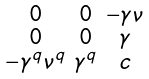<formula> <loc_0><loc_0><loc_500><loc_500>\begin{smallmatrix} 0 & 0 & - \gamma \nu \\ 0 & 0 & \gamma \\ - \gamma ^ { q } \nu ^ { q } & \gamma ^ { q } & c \\ \end{smallmatrix}</formula> 